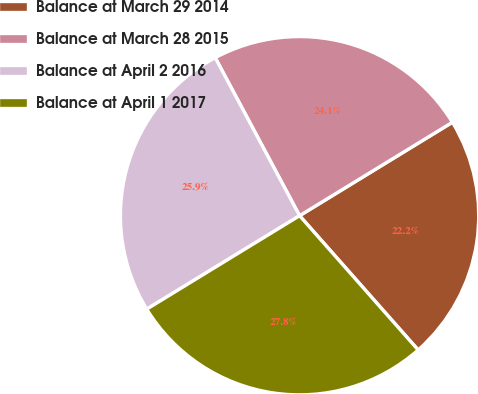Convert chart. <chart><loc_0><loc_0><loc_500><loc_500><pie_chart><fcel>Balance at March 29 2014<fcel>Balance at March 28 2015<fcel>Balance at April 2 2016<fcel>Balance at April 1 2017<nl><fcel>22.22%<fcel>24.07%<fcel>25.93%<fcel>27.78%<nl></chart> 